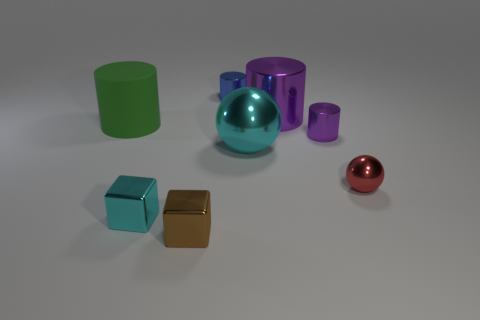There is a purple cylinder that is the same material as the tiny purple object; what is its size?
Make the answer very short. Large. Is there any other thing that is made of the same material as the green thing?
Keep it short and to the point. No. There is a red metallic ball; is it the same size as the metal ball behind the red thing?
Offer a very short reply. No. What number of other objects are there of the same color as the large rubber thing?
Your answer should be very brief. 0. Are there any metallic objects to the right of the blue metal thing?
Your answer should be compact. Yes. What number of objects are small blue things or rubber things in front of the blue thing?
Provide a short and direct response. 2. There is a large sphere that is behind the red thing; are there any small purple metal objects that are in front of it?
Your answer should be compact. No. There is a metallic thing that is behind the big metallic object that is to the right of the sphere behind the red ball; what is its shape?
Give a very brief answer. Cylinder. There is a tiny metallic object that is both in front of the tiny red metallic thing and behind the brown shiny thing; what is its color?
Your response must be concise. Cyan. What shape is the purple metallic object that is to the right of the big purple metal cylinder?
Your answer should be compact. Cylinder. 